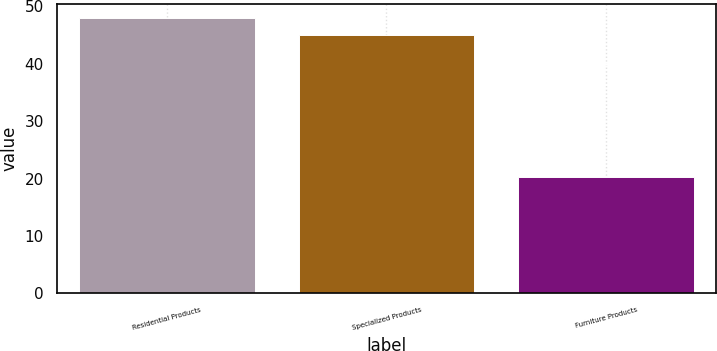Convert chart to OTSL. <chart><loc_0><loc_0><loc_500><loc_500><bar_chart><fcel>Residential Products<fcel>Specialized Products<fcel>Furniture Products<nl><fcel>48<fcel>45<fcel>20.2<nl></chart> 